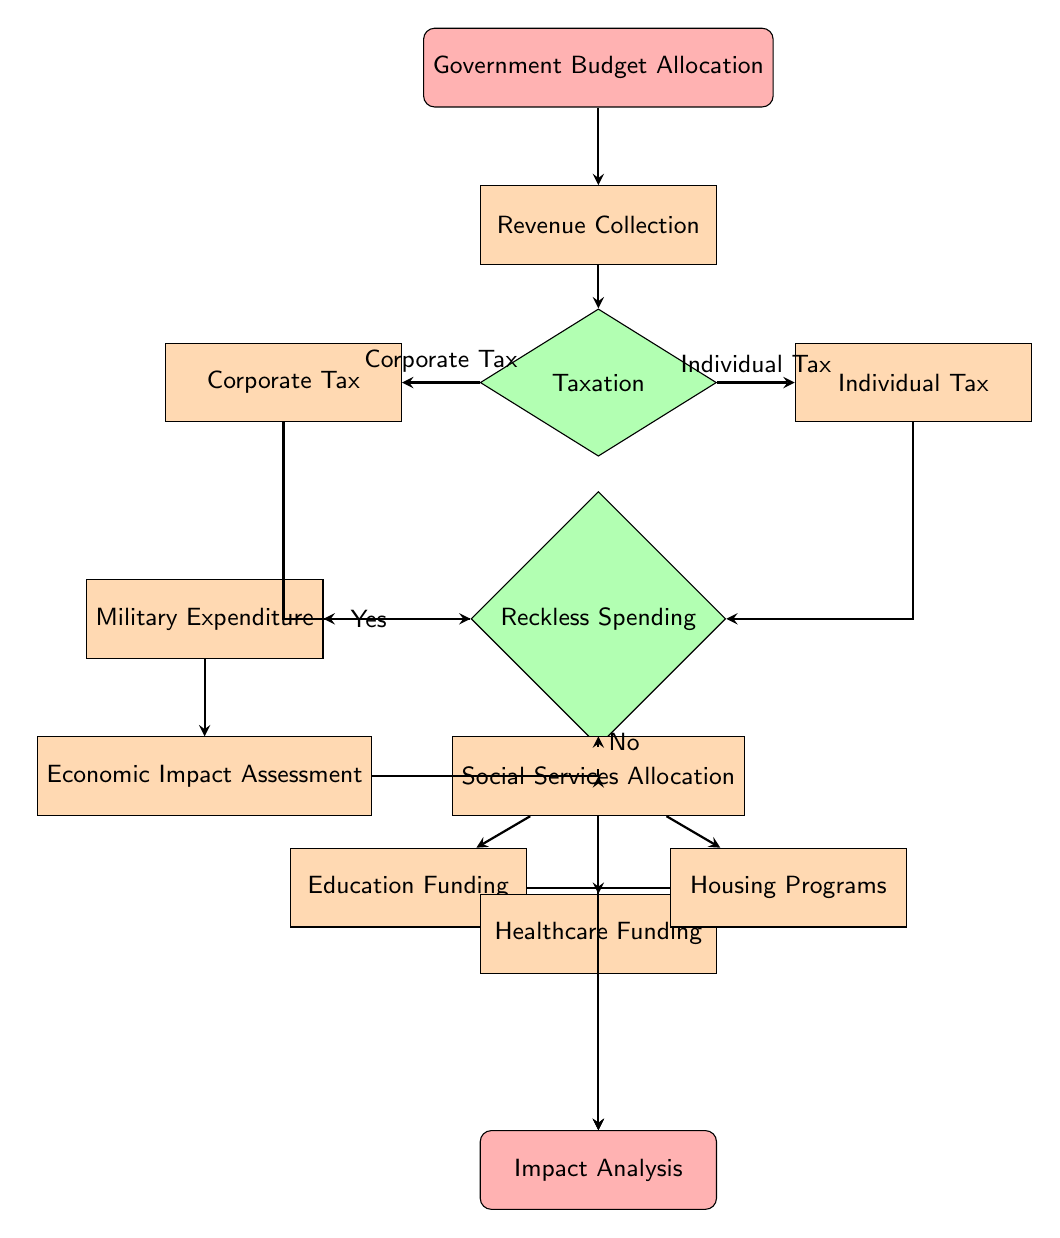What is the starting point of the flow chart? The flow chart begins with the node labeled "Government Budget Allocation," which is the first step in the process.
Answer: Government Budget Allocation How many types of taxes are collected in the revenue collection process? There are two types of taxes shown in the diagram: Corporate Tax and Individual Tax, both of which branch from the Taxation decision node.
Answer: Two What is the decision made after Taxation regarding spending? The decision made is whether there is Reckless Spending; this is a key junction in determining the next steps in the flow.
Answer: Reckless Spending If there is reckless spending, what is the next expenditure type? If reckless spending is confirmed (Yes), the next expenditure type is Military Expenditure, which follows in the flow based on the decision path.
Answer: Military Expenditure What three areas fall under Social Services Allocation? The Social Services Allocation leads to three specific areas: Education Funding, Healthcare Funding, and Housing Programs, each connected to the social services node.
Answer: Education Funding, Healthcare Funding, Housing Programs What happens to Economic Impact Assessment in the flow? After the Military Expenditure step, the flow proceeds to Economic Impact Assessment, indicating the analysis of the effects of military spending.
Answer: It follows Military Expenditure How do expenditures affect education, healthcare, and housing? The expenditures for Education Funding, Healthcare Funding, and Housing Programs all culminate in the final node, Impact Analysis, indicating their implications are evaluated collectively.
Answer: Impact Analysis What happens if there is no reckless spending? If there is no reckless spending (No), the flow directly progresses to Social Services Allocation, which outlines how the budget will be used for social programs.
Answer: Social Services Allocation Who assesses the impact of all these allocations? The impact of the allocations is assessed in the final node labeled "Impact Analysis," which gathers the effects of all expenditures made through the process.
Answer: Impact Analysis 